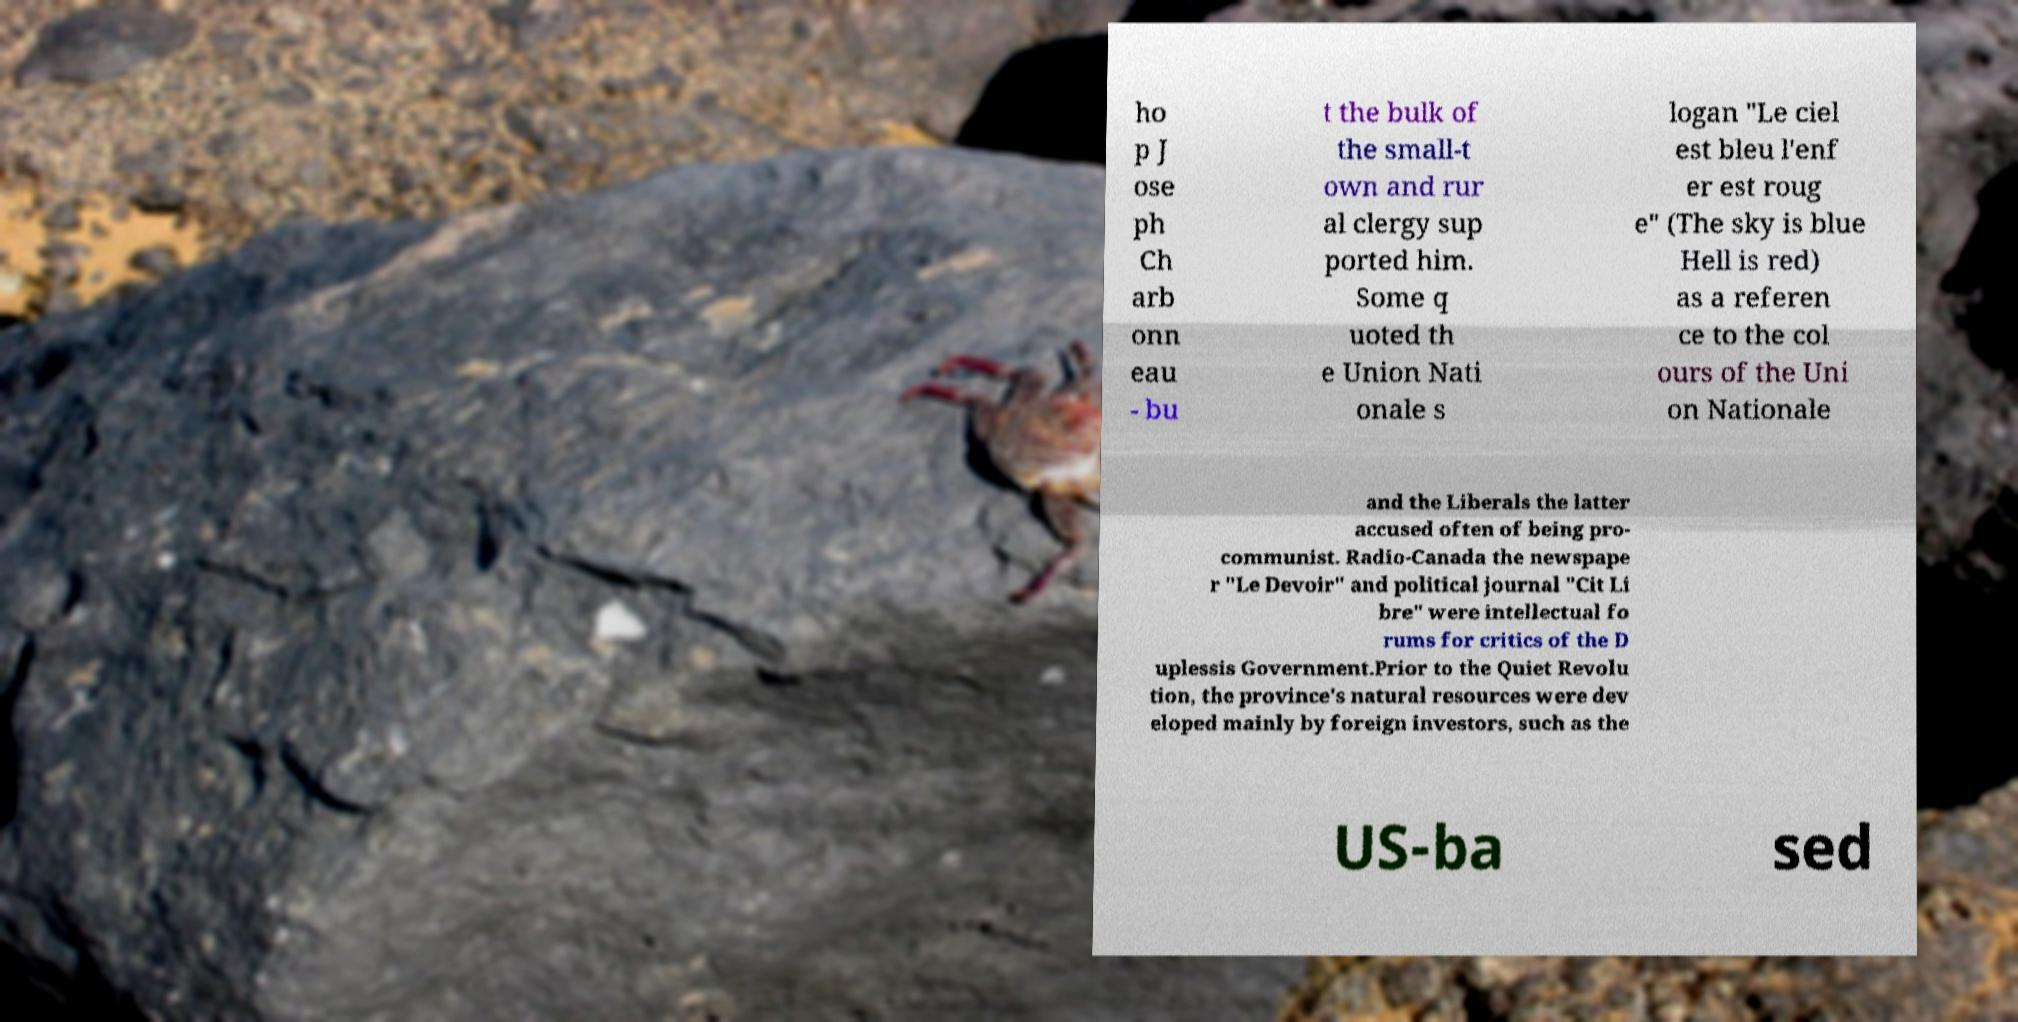For documentation purposes, I need the text within this image transcribed. Could you provide that? ho p J ose ph Ch arb onn eau - bu t the bulk of the small-t own and rur al clergy sup ported him. Some q uoted th e Union Nati onale s logan "Le ciel est bleu l'enf er est roug e" (The sky is blue Hell is red) as a referen ce to the col ours of the Uni on Nationale and the Liberals the latter accused often of being pro- communist. Radio-Canada the newspape r "Le Devoir" and political journal "Cit Li bre" were intellectual fo rums for critics of the D uplessis Government.Prior to the Quiet Revolu tion, the province's natural resources were dev eloped mainly by foreign investors, such as the US-ba sed 